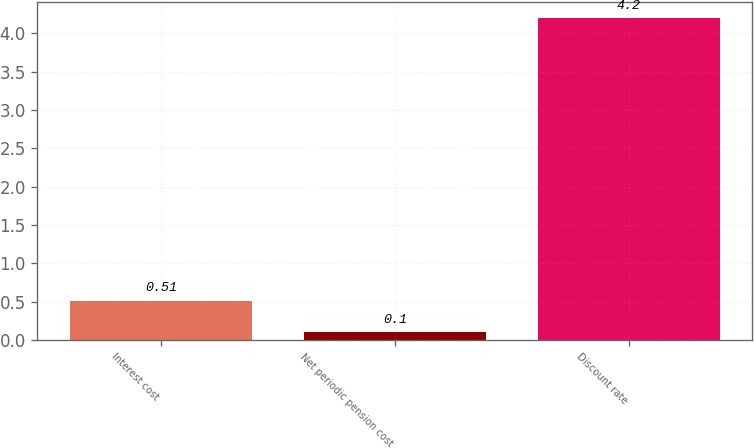<chart> <loc_0><loc_0><loc_500><loc_500><bar_chart><fcel>Interest cost<fcel>Net periodic pension cost<fcel>Discount rate<nl><fcel>0.51<fcel>0.1<fcel>4.2<nl></chart> 